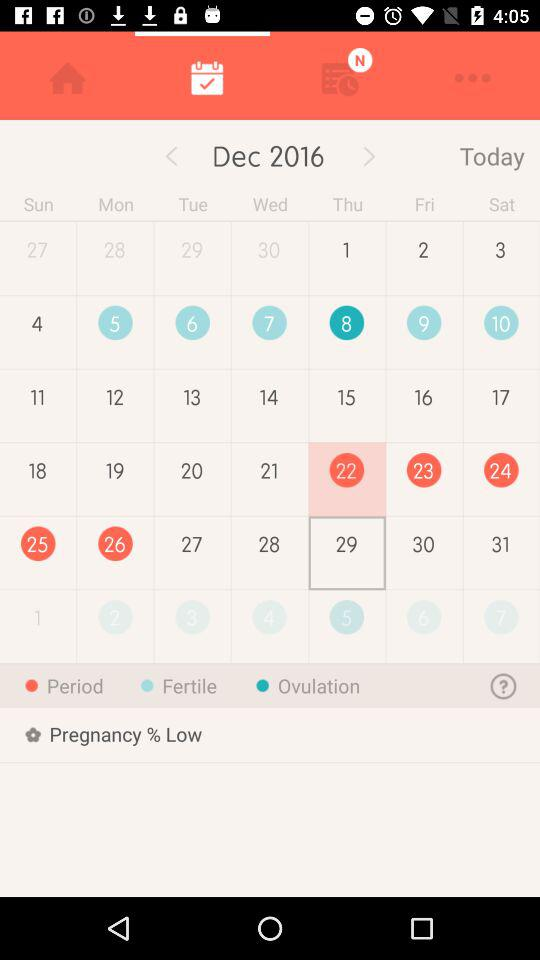What are the period dates? The period dates are from December 22nd to December 26th. 